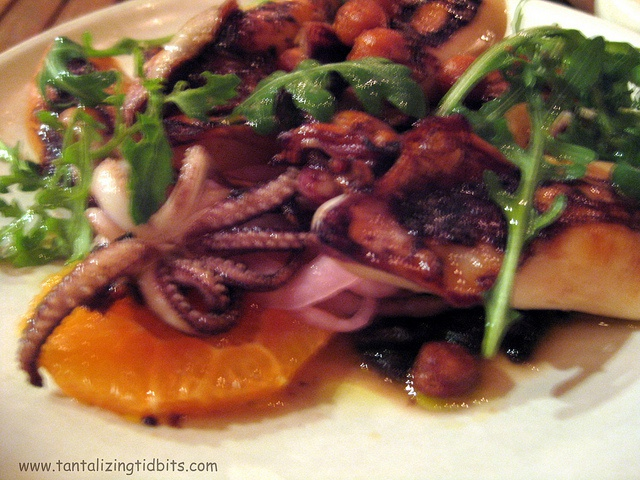Describe the objects in this image and their specific colors. I can see a orange in tan, red, brown, and orange tones in this image. 